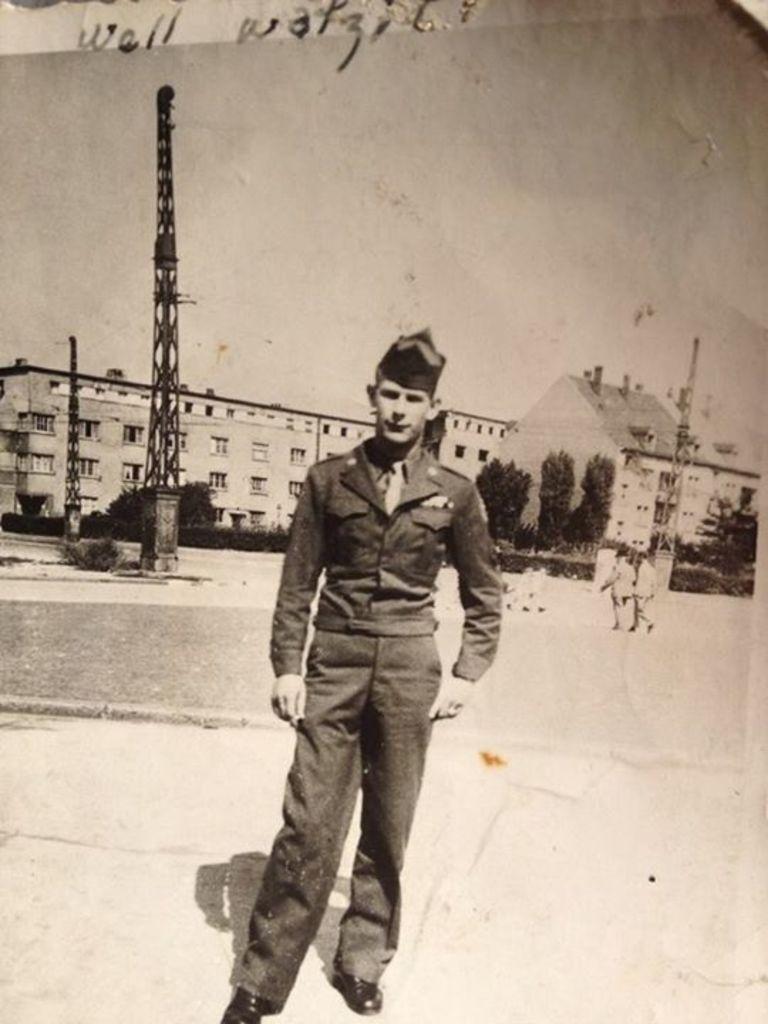Please provide a concise description of this image. In this image we can see a few people, there are buildings, trees, plants, towers, also we can see the sky, and there is a text on the image. 